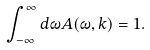Convert formula to latex. <formula><loc_0><loc_0><loc_500><loc_500>\int _ { - \infty } ^ { \infty } d \omega A ( \omega , k ) = 1 .</formula> 